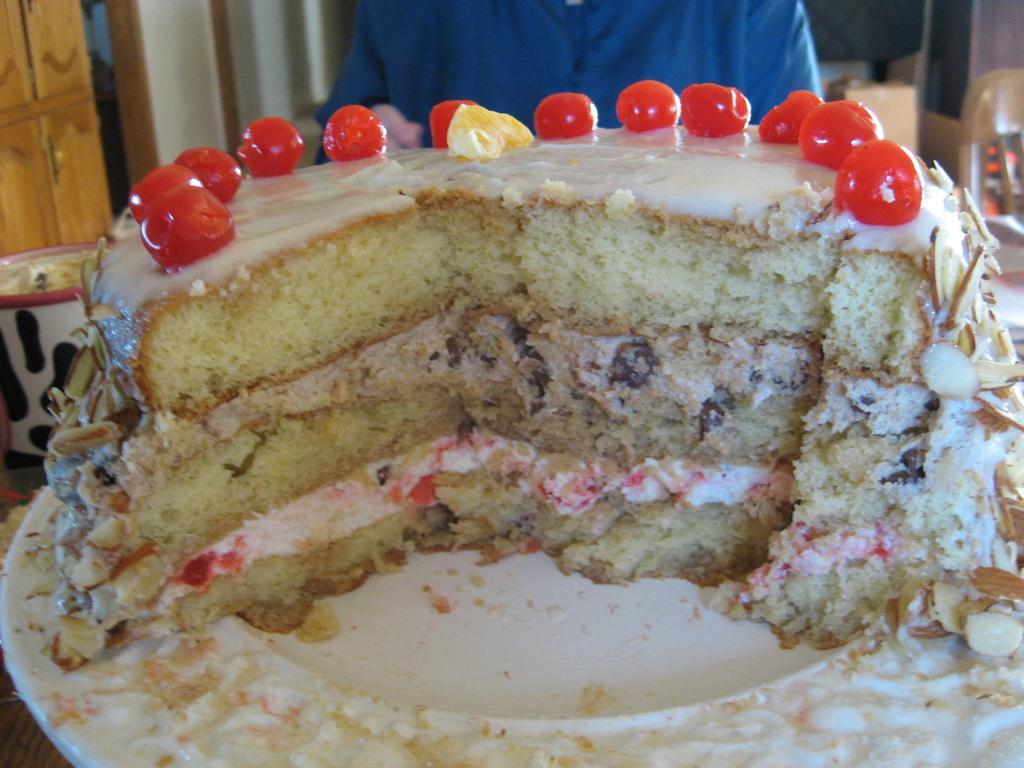How would you summarize this image in a sentence or two? In this image on a plate there is a cake. Here there is a person. This is a door. In the background there are many other things. 